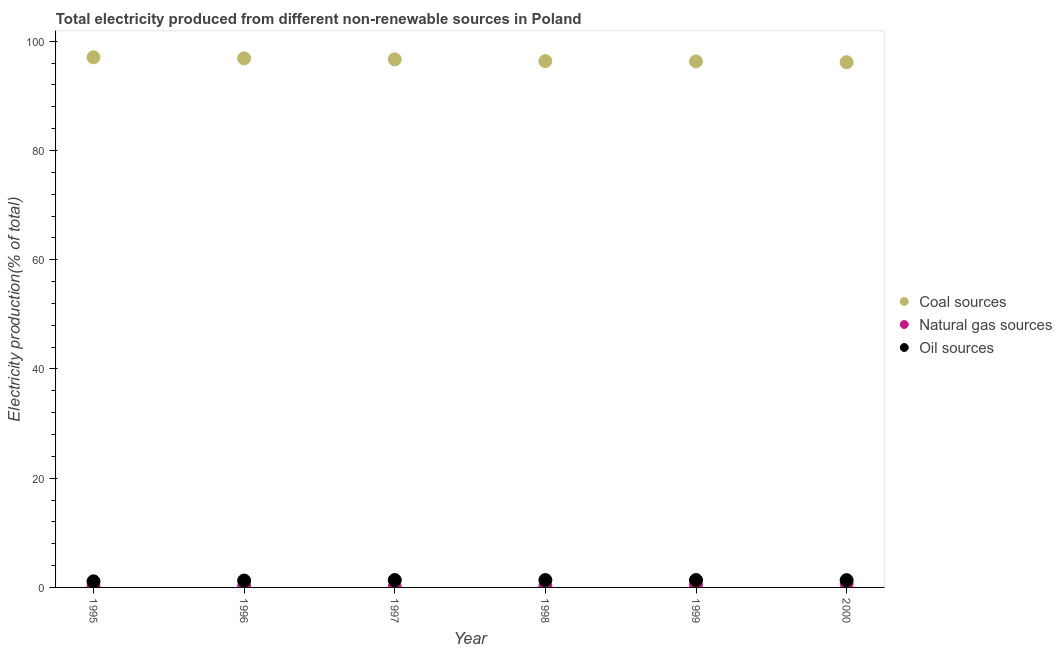How many different coloured dotlines are there?
Provide a succinct answer. 3. What is the percentage of electricity produced by natural gas in 1999?
Provide a short and direct response. 0.44. Across all years, what is the maximum percentage of electricity produced by oil sources?
Keep it short and to the point. 1.35. Across all years, what is the minimum percentage of electricity produced by natural gas?
Offer a terse response. 0.15. In which year was the percentage of electricity produced by oil sources maximum?
Your answer should be very brief. 1998. What is the total percentage of electricity produced by coal in the graph?
Offer a very short reply. 579.41. What is the difference between the percentage of electricity produced by oil sources in 1997 and that in 1998?
Your answer should be compact. -0. What is the difference between the percentage of electricity produced by oil sources in 1997 and the percentage of electricity produced by natural gas in 1998?
Provide a short and direct response. 1.13. What is the average percentage of electricity produced by natural gas per year?
Provide a succinct answer. 0.31. In the year 1999, what is the difference between the percentage of electricity produced by oil sources and percentage of electricity produced by natural gas?
Your answer should be very brief. 0.91. In how many years, is the percentage of electricity produced by natural gas greater than 80 %?
Offer a terse response. 0. What is the ratio of the percentage of electricity produced by oil sources in 1998 to that in 1999?
Keep it short and to the point. 1. Is the percentage of electricity produced by oil sources in 1998 less than that in 2000?
Offer a terse response. No. What is the difference between the highest and the second highest percentage of electricity produced by oil sources?
Offer a terse response. 0. What is the difference between the highest and the lowest percentage of electricity produced by coal?
Keep it short and to the point. 0.9. In how many years, is the percentage of electricity produced by natural gas greater than the average percentage of electricity produced by natural gas taken over all years?
Offer a very short reply. 2. Is the sum of the percentage of electricity produced by coal in 1995 and 1998 greater than the maximum percentage of electricity produced by natural gas across all years?
Make the answer very short. Yes. Does the percentage of electricity produced by natural gas monotonically increase over the years?
Your answer should be very brief. No. How many years are there in the graph?
Your answer should be compact. 6. What is the difference between two consecutive major ticks on the Y-axis?
Ensure brevity in your answer.  20. Are the values on the major ticks of Y-axis written in scientific E-notation?
Offer a terse response. No. Does the graph contain any zero values?
Your answer should be compact. No. Does the graph contain grids?
Your answer should be very brief. No. Where does the legend appear in the graph?
Keep it short and to the point. Center right. How many legend labels are there?
Provide a succinct answer. 3. What is the title of the graph?
Provide a short and direct response. Total electricity produced from different non-renewable sources in Poland. What is the Electricity production(% of total) in Coal sources in 1995?
Your answer should be very brief. 97.06. What is the Electricity production(% of total) in Natural gas sources in 1995?
Give a very brief answer. 0.19. What is the Electricity production(% of total) in Oil sources in 1995?
Your answer should be very brief. 1.11. What is the Electricity production(% of total) in Coal sources in 1996?
Your answer should be compact. 96.86. What is the Electricity production(% of total) of Natural gas sources in 1996?
Your answer should be compact. 0.23. What is the Electricity production(% of total) of Oil sources in 1996?
Your answer should be compact. 1.26. What is the Electricity production(% of total) in Coal sources in 1997?
Your answer should be very brief. 96.68. What is the Electricity production(% of total) in Natural gas sources in 1997?
Keep it short and to the point. 0.15. What is the Electricity production(% of total) in Oil sources in 1997?
Your answer should be compact. 1.35. What is the Electricity production(% of total) in Coal sources in 1998?
Provide a succinct answer. 96.36. What is the Electricity production(% of total) of Natural gas sources in 1998?
Provide a short and direct response. 0.22. What is the Electricity production(% of total) of Oil sources in 1998?
Give a very brief answer. 1.35. What is the Electricity production(% of total) in Coal sources in 1999?
Your response must be concise. 96.3. What is the Electricity production(% of total) in Natural gas sources in 1999?
Provide a short and direct response. 0.44. What is the Electricity production(% of total) in Oil sources in 1999?
Give a very brief answer. 1.35. What is the Electricity production(% of total) in Coal sources in 2000?
Offer a terse response. 96.15. What is the Electricity production(% of total) of Natural gas sources in 2000?
Give a very brief answer. 0.65. What is the Electricity production(% of total) of Oil sources in 2000?
Offer a terse response. 1.34. Across all years, what is the maximum Electricity production(% of total) of Coal sources?
Offer a very short reply. 97.06. Across all years, what is the maximum Electricity production(% of total) in Natural gas sources?
Provide a succinct answer. 0.65. Across all years, what is the maximum Electricity production(% of total) of Oil sources?
Ensure brevity in your answer.  1.35. Across all years, what is the minimum Electricity production(% of total) in Coal sources?
Make the answer very short. 96.15. Across all years, what is the minimum Electricity production(% of total) in Natural gas sources?
Give a very brief answer. 0.15. Across all years, what is the minimum Electricity production(% of total) in Oil sources?
Give a very brief answer. 1.11. What is the total Electricity production(% of total) in Coal sources in the graph?
Make the answer very short. 579.41. What is the total Electricity production(% of total) of Natural gas sources in the graph?
Your answer should be compact. 1.88. What is the total Electricity production(% of total) in Oil sources in the graph?
Your answer should be compact. 7.76. What is the difference between the Electricity production(% of total) of Coal sources in 1995 and that in 1996?
Keep it short and to the point. 0.19. What is the difference between the Electricity production(% of total) of Natural gas sources in 1995 and that in 1996?
Ensure brevity in your answer.  -0.04. What is the difference between the Electricity production(% of total) of Oil sources in 1995 and that in 1996?
Provide a succinct answer. -0.14. What is the difference between the Electricity production(% of total) in Coal sources in 1995 and that in 1997?
Offer a terse response. 0.38. What is the difference between the Electricity production(% of total) in Natural gas sources in 1995 and that in 1997?
Offer a very short reply. 0.04. What is the difference between the Electricity production(% of total) of Oil sources in 1995 and that in 1997?
Your answer should be compact. -0.24. What is the difference between the Electricity production(% of total) of Coal sources in 1995 and that in 1998?
Ensure brevity in your answer.  0.7. What is the difference between the Electricity production(% of total) in Natural gas sources in 1995 and that in 1998?
Make the answer very short. -0.03. What is the difference between the Electricity production(% of total) of Oil sources in 1995 and that in 1998?
Offer a terse response. -0.24. What is the difference between the Electricity production(% of total) in Coal sources in 1995 and that in 1999?
Give a very brief answer. 0.75. What is the difference between the Electricity production(% of total) of Natural gas sources in 1995 and that in 1999?
Offer a terse response. -0.25. What is the difference between the Electricity production(% of total) of Oil sources in 1995 and that in 1999?
Provide a succinct answer. -0.24. What is the difference between the Electricity production(% of total) in Coal sources in 1995 and that in 2000?
Offer a terse response. 0.9. What is the difference between the Electricity production(% of total) of Natural gas sources in 1995 and that in 2000?
Make the answer very short. -0.46. What is the difference between the Electricity production(% of total) in Oil sources in 1995 and that in 2000?
Offer a terse response. -0.23. What is the difference between the Electricity production(% of total) in Coal sources in 1996 and that in 1997?
Keep it short and to the point. 0.18. What is the difference between the Electricity production(% of total) of Natural gas sources in 1996 and that in 1997?
Your answer should be very brief. 0.08. What is the difference between the Electricity production(% of total) in Oil sources in 1996 and that in 1997?
Provide a short and direct response. -0.09. What is the difference between the Electricity production(% of total) of Coal sources in 1996 and that in 1998?
Your answer should be very brief. 0.5. What is the difference between the Electricity production(% of total) of Natural gas sources in 1996 and that in 1998?
Provide a short and direct response. 0.01. What is the difference between the Electricity production(% of total) of Oil sources in 1996 and that in 1998?
Offer a terse response. -0.1. What is the difference between the Electricity production(% of total) of Coal sources in 1996 and that in 1999?
Provide a succinct answer. 0.56. What is the difference between the Electricity production(% of total) of Natural gas sources in 1996 and that in 1999?
Ensure brevity in your answer.  -0.21. What is the difference between the Electricity production(% of total) of Oil sources in 1996 and that in 1999?
Make the answer very short. -0.1. What is the difference between the Electricity production(% of total) in Coal sources in 1996 and that in 2000?
Ensure brevity in your answer.  0.71. What is the difference between the Electricity production(% of total) in Natural gas sources in 1996 and that in 2000?
Make the answer very short. -0.42. What is the difference between the Electricity production(% of total) in Oil sources in 1996 and that in 2000?
Offer a terse response. -0.08. What is the difference between the Electricity production(% of total) of Coal sources in 1997 and that in 1998?
Offer a very short reply. 0.32. What is the difference between the Electricity production(% of total) of Natural gas sources in 1997 and that in 1998?
Your answer should be very brief. -0.07. What is the difference between the Electricity production(% of total) in Oil sources in 1997 and that in 1998?
Provide a short and direct response. -0. What is the difference between the Electricity production(% of total) in Coal sources in 1997 and that in 1999?
Make the answer very short. 0.38. What is the difference between the Electricity production(% of total) of Natural gas sources in 1997 and that in 1999?
Give a very brief answer. -0.29. What is the difference between the Electricity production(% of total) of Oil sources in 1997 and that in 1999?
Provide a succinct answer. -0. What is the difference between the Electricity production(% of total) in Coal sources in 1997 and that in 2000?
Ensure brevity in your answer.  0.52. What is the difference between the Electricity production(% of total) of Natural gas sources in 1997 and that in 2000?
Provide a succinct answer. -0.5. What is the difference between the Electricity production(% of total) in Oil sources in 1997 and that in 2000?
Offer a terse response. 0.01. What is the difference between the Electricity production(% of total) of Coal sources in 1998 and that in 1999?
Offer a terse response. 0.06. What is the difference between the Electricity production(% of total) of Natural gas sources in 1998 and that in 1999?
Offer a terse response. -0.22. What is the difference between the Electricity production(% of total) of Coal sources in 1998 and that in 2000?
Offer a terse response. 0.21. What is the difference between the Electricity production(% of total) in Natural gas sources in 1998 and that in 2000?
Your answer should be very brief. -0.43. What is the difference between the Electricity production(% of total) of Oil sources in 1998 and that in 2000?
Your answer should be very brief. 0.01. What is the difference between the Electricity production(% of total) in Coal sources in 1999 and that in 2000?
Offer a terse response. 0.15. What is the difference between the Electricity production(% of total) in Natural gas sources in 1999 and that in 2000?
Your response must be concise. -0.21. What is the difference between the Electricity production(% of total) of Oil sources in 1999 and that in 2000?
Make the answer very short. 0.01. What is the difference between the Electricity production(% of total) in Coal sources in 1995 and the Electricity production(% of total) in Natural gas sources in 1996?
Ensure brevity in your answer.  96.83. What is the difference between the Electricity production(% of total) in Coal sources in 1995 and the Electricity production(% of total) in Oil sources in 1996?
Provide a succinct answer. 95.8. What is the difference between the Electricity production(% of total) of Natural gas sources in 1995 and the Electricity production(% of total) of Oil sources in 1996?
Keep it short and to the point. -1.07. What is the difference between the Electricity production(% of total) in Coal sources in 1995 and the Electricity production(% of total) in Natural gas sources in 1997?
Provide a short and direct response. 96.9. What is the difference between the Electricity production(% of total) of Coal sources in 1995 and the Electricity production(% of total) of Oil sources in 1997?
Ensure brevity in your answer.  95.71. What is the difference between the Electricity production(% of total) of Natural gas sources in 1995 and the Electricity production(% of total) of Oil sources in 1997?
Your answer should be very brief. -1.16. What is the difference between the Electricity production(% of total) of Coal sources in 1995 and the Electricity production(% of total) of Natural gas sources in 1998?
Keep it short and to the point. 96.83. What is the difference between the Electricity production(% of total) in Coal sources in 1995 and the Electricity production(% of total) in Oil sources in 1998?
Provide a succinct answer. 95.71. What is the difference between the Electricity production(% of total) in Natural gas sources in 1995 and the Electricity production(% of total) in Oil sources in 1998?
Give a very brief answer. -1.16. What is the difference between the Electricity production(% of total) in Coal sources in 1995 and the Electricity production(% of total) in Natural gas sources in 1999?
Make the answer very short. 96.61. What is the difference between the Electricity production(% of total) of Coal sources in 1995 and the Electricity production(% of total) of Oil sources in 1999?
Offer a very short reply. 95.71. What is the difference between the Electricity production(% of total) of Natural gas sources in 1995 and the Electricity production(% of total) of Oil sources in 1999?
Provide a short and direct response. -1.16. What is the difference between the Electricity production(% of total) of Coal sources in 1995 and the Electricity production(% of total) of Natural gas sources in 2000?
Your answer should be very brief. 96.41. What is the difference between the Electricity production(% of total) of Coal sources in 1995 and the Electricity production(% of total) of Oil sources in 2000?
Your response must be concise. 95.72. What is the difference between the Electricity production(% of total) of Natural gas sources in 1995 and the Electricity production(% of total) of Oil sources in 2000?
Your answer should be compact. -1.15. What is the difference between the Electricity production(% of total) of Coal sources in 1996 and the Electricity production(% of total) of Natural gas sources in 1997?
Provide a succinct answer. 96.71. What is the difference between the Electricity production(% of total) in Coal sources in 1996 and the Electricity production(% of total) in Oil sources in 1997?
Keep it short and to the point. 95.51. What is the difference between the Electricity production(% of total) of Natural gas sources in 1996 and the Electricity production(% of total) of Oil sources in 1997?
Your response must be concise. -1.12. What is the difference between the Electricity production(% of total) in Coal sources in 1996 and the Electricity production(% of total) in Natural gas sources in 1998?
Your answer should be very brief. 96.64. What is the difference between the Electricity production(% of total) of Coal sources in 1996 and the Electricity production(% of total) of Oil sources in 1998?
Your answer should be compact. 95.51. What is the difference between the Electricity production(% of total) in Natural gas sources in 1996 and the Electricity production(% of total) in Oil sources in 1998?
Give a very brief answer. -1.12. What is the difference between the Electricity production(% of total) in Coal sources in 1996 and the Electricity production(% of total) in Natural gas sources in 1999?
Give a very brief answer. 96.42. What is the difference between the Electricity production(% of total) of Coal sources in 1996 and the Electricity production(% of total) of Oil sources in 1999?
Make the answer very short. 95.51. What is the difference between the Electricity production(% of total) of Natural gas sources in 1996 and the Electricity production(% of total) of Oil sources in 1999?
Your answer should be compact. -1.12. What is the difference between the Electricity production(% of total) of Coal sources in 1996 and the Electricity production(% of total) of Natural gas sources in 2000?
Provide a short and direct response. 96.21. What is the difference between the Electricity production(% of total) of Coal sources in 1996 and the Electricity production(% of total) of Oil sources in 2000?
Offer a very short reply. 95.52. What is the difference between the Electricity production(% of total) in Natural gas sources in 1996 and the Electricity production(% of total) in Oil sources in 2000?
Provide a succinct answer. -1.11. What is the difference between the Electricity production(% of total) in Coal sources in 1997 and the Electricity production(% of total) in Natural gas sources in 1998?
Ensure brevity in your answer.  96.46. What is the difference between the Electricity production(% of total) of Coal sources in 1997 and the Electricity production(% of total) of Oil sources in 1998?
Your answer should be very brief. 95.33. What is the difference between the Electricity production(% of total) of Natural gas sources in 1997 and the Electricity production(% of total) of Oil sources in 1998?
Your answer should be compact. -1.2. What is the difference between the Electricity production(% of total) of Coal sources in 1997 and the Electricity production(% of total) of Natural gas sources in 1999?
Ensure brevity in your answer.  96.23. What is the difference between the Electricity production(% of total) of Coal sources in 1997 and the Electricity production(% of total) of Oil sources in 1999?
Ensure brevity in your answer.  95.33. What is the difference between the Electricity production(% of total) of Natural gas sources in 1997 and the Electricity production(% of total) of Oil sources in 1999?
Ensure brevity in your answer.  -1.2. What is the difference between the Electricity production(% of total) of Coal sources in 1997 and the Electricity production(% of total) of Natural gas sources in 2000?
Your answer should be very brief. 96.03. What is the difference between the Electricity production(% of total) of Coal sources in 1997 and the Electricity production(% of total) of Oil sources in 2000?
Your answer should be very brief. 95.34. What is the difference between the Electricity production(% of total) of Natural gas sources in 1997 and the Electricity production(% of total) of Oil sources in 2000?
Provide a short and direct response. -1.19. What is the difference between the Electricity production(% of total) in Coal sources in 1998 and the Electricity production(% of total) in Natural gas sources in 1999?
Offer a terse response. 95.92. What is the difference between the Electricity production(% of total) of Coal sources in 1998 and the Electricity production(% of total) of Oil sources in 1999?
Ensure brevity in your answer.  95.01. What is the difference between the Electricity production(% of total) of Natural gas sources in 1998 and the Electricity production(% of total) of Oil sources in 1999?
Offer a very short reply. -1.13. What is the difference between the Electricity production(% of total) in Coal sources in 1998 and the Electricity production(% of total) in Natural gas sources in 2000?
Offer a terse response. 95.71. What is the difference between the Electricity production(% of total) in Coal sources in 1998 and the Electricity production(% of total) in Oil sources in 2000?
Provide a succinct answer. 95.02. What is the difference between the Electricity production(% of total) in Natural gas sources in 1998 and the Electricity production(% of total) in Oil sources in 2000?
Your response must be concise. -1.12. What is the difference between the Electricity production(% of total) in Coal sources in 1999 and the Electricity production(% of total) in Natural gas sources in 2000?
Ensure brevity in your answer.  95.65. What is the difference between the Electricity production(% of total) of Coal sources in 1999 and the Electricity production(% of total) of Oil sources in 2000?
Make the answer very short. 94.96. What is the difference between the Electricity production(% of total) of Natural gas sources in 1999 and the Electricity production(% of total) of Oil sources in 2000?
Offer a very short reply. -0.9. What is the average Electricity production(% of total) in Coal sources per year?
Give a very brief answer. 96.57. What is the average Electricity production(% of total) in Natural gas sources per year?
Provide a succinct answer. 0.31. What is the average Electricity production(% of total) of Oil sources per year?
Provide a succinct answer. 1.29. In the year 1995, what is the difference between the Electricity production(% of total) of Coal sources and Electricity production(% of total) of Natural gas sources?
Give a very brief answer. 96.87. In the year 1995, what is the difference between the Electricity production(% of total) in Coal sources and Electricity production(% of total) in Oil sources?
Your answer should be compact. 95.95. In the year 1995, what is the difference between the Electricity production(% of total) in Natural gas sources and Electricity production(% of total) in Oil sources?
Make the answer very short. -0.92. In the year 1996, what is the difference between the Electricity production(% of total) in Coal sources and Electricity production(% of total) in Natural gas sources?
Ensure brevity in your answer.  96.63. In the year 1996, what is the difference between the Electricity production(% of total) of Coal sources and Electricity production(% of total) of Oil sources?
Offer a terse response. 95.61. In the year 1996, what is the difference between the Electricity production(% of total) in Natural gas sources and Electricity production(% of total) in Oil sources?
Give a very brief answer. -1.03. In the year 1997, what is the difference between the Electricity production(% of total) of Coal sources and Electricity production(% of total) of Natural gas sources?
Make the answer very short. 96.53. In the year 1997, what is the difference between the Electricity production(% of total) of Coal sources and Electricity production(% of total) of Oil sources?
Your answer should be very brief. 95.33. In the year 1997, what is the difference between the Electricity production(% of total) in Natural gas sources and Electricity production(% of total) in Oil sources?
Keep it short and to the point. -1.2. In the year 1998, what is the difference between the Electricity production(% of total) in Coal sources and Electricity production(% of total) in Natural gas sources?
Keep it short and to the point. 96.14. In the year 1998, what is the difference between the Electricity production(% of total) in Coal sources and Electricity production(% of total) in Oil sources?
Make the answer very short. 95.01. In the year 1998, what is the difference between the Electricity production(% of total) of Natural gas sources and Electricity production(% of total) of Oil sources?
Keep it short and to the point. -1.13. In the year 1999, what is the difference between the Electricity production(% of total) in Coal sources and Electricity production(% of total) in Natural gas sources?
Keep it short and to the point. 95.86. In the year 1999, what is the difference between the Electricity production(% of total) of Coal sources and Electricity production(% of total) of Oil sources?
Ensure brevity in your answer.  94.95. In the year 1999, what is the difference between the Electricity production(% of total) of Natural gas sources and Electricity production(% of total) of Oil sources?
Give a very brief answer. -0.91. In the year 2000, what is the difference between the Electricity production(% of total) of Coal sources and Electricity production(% of total) of Natural gas sources?
Give a very brief answer. 95.51. In the year 2000, what is the difference between the Electricity production(% of total) in Coal sources and Electricity production(% of total) in Oil sources?
Your answer should be compact. 94.82. In the year 2000, what is the difference between the Electricity production(% of total) of Natural gas sources and Electricity production(% of total) of Oil sources?
Your answer should be compact. -0.69. What is the ratio of the Electricity production(% of total) in Natural gas sources in 1995 to that in 1996?
Your answer should be compact. 0.82. What is the ratio of the Electricity production(% of total) in Oil sources in 1995 to that in 1996?
Provide a short and direct response. 0.89. What is the ratio of the Electricity production(% of total) of Coal sources in 1995 to that in 1997?
Offer a terse response. 1. What is the ratio of the Electricity production(% of total) of Natural gas sources in 1995 to that in 1997?
Your response must be concise. 1.23. What is the ratio of the Electricity production(% of total) of Oil sources in 1995 to that in 1997?
Offer a very short reply. 0.82. What is the ratio of the Electricity production(% of total) of Natural gas sources in 1995 to that in 1998?
Offer a terse response. 0.85. What is the ratio of the Electricity production(% of total) in Oil sources in 1995 to that in 1998?
Your answer should be compact. 0.82. What is the ratio of the Electricity production(% of total) in Coal sources in 1995 to that in 1999?
Your answer should be very brief. 1.01. What is the ratio of the Electricity production(% of total) in Natural gas sources in 1995 to that in 1999?
Provide a succinct answer. 0.43. What is the ratio of the Electricity production(% of total) in Oil sources in 1995 to that in 1999?
Offer a very short reply. 0.82. What is the ratio of the Electricity production(% of total) in Coal sources in 1995 to that in 2000?
Offer a terse response. 1.01. What is the ratio of the Electricity production(% of total) in Natural gas sources in 1995 to that in 2000?
Your answer should be very brief. 0.29. What is the ratio of the Electricity production(% of total) in Oil sources in 1995 to that in 2000?
Provide a short and direct response. 0.83. What is the ratio of the Electricity production(% of total) in Natural gas sources in 1996 to that in 1997?
Your answer should be very brief. 1.5. What is the ratio of the Electricity production(% of total) in Oil sources in 1996 to that in 1997?
Your response must be concise. 0.93. What is the ratio of the Electricity production(% of total) in Natural gas sources in 1996 to that in 1998?
Provide a succinct answer. 1.03. What is the ratio of the Electricity production(% of total) in Oil sources in 1996 to that in 1998?
Ensure brevity in your answer.  0.93. What is the ratio of the Electricity production(% of total) in Coal sources in 1996 to that in 1999?
Provide a succinct answer. 1.01. What is the ratio of the Electricity production(% of total) in Natural gas sources in 1996 to that in 1999?
Your answer should be compact. 0.52. What is the ratio of the Electricity production(% of total) of Oil sources in 1996 to that in 1999?
Keep it short and to the point. 0.93. What is the ratio of the Electricity production(% of total) of Coal sources in 1996 to that in 2000?
Ensure brevity in your answer.  1.01. What is the ratio of the Electricity production(% of total) of Natural gas sources in 1996 to that in 2000?
Offer a terse response. 0.35. What is the ratio of the Electricity production(% of total) in Oil sources in 1996 to that in 2000?
Offer a very short reply. 0.94. What is the ratio of the Electricity production(% of total) in Coal sources in 1997 to that in 1998?
Give a very brief answer. 1. What is the ratio of the Electricity production(% of total) in Natural gas sources in 1997 to that in 1998?
Your response must be concise. 0.69. What is the ratio of the Electricity production(% of total) of Oil sources in 1997 to that in 1998?
Make the answer very short. 1. What is the ratio of the Electricity production(% of total) of Coal sources in 1997 to that in 1999?
Your answer should be very brief. 1. What is the ratio of the Electricity production(% of total) of Natural gas sources in 1997 to that in 1999?
Ensure brevity in your answer.  0.34. What is the ratio of the Electricity production(% of total) in Oil sources in 1997 to that in 1999?
Provide a succinct answer. 1. What is the ratio of the Electricity production(% of total) of Natural gas sources in 1997 to that in 2000?
Give a very brief answer. 0.24. What is the ratio of the Electricity production(% of total) in Oil sources in 1997 to that in 2000?
Offer a very short reply. 1.01. What is the ratio of the Electricity production(% of total) of Coal sources in 1998 to that in 1999?
Provide a succinct answer. 1. What is the ratio of the Electricity production(% of total) in Natural gas sources in 1998 to that in 1999?
Make the answer very short. 0.5. What is the ratio of the Electricity production(% of total) in Coal sources in 1998 to that in 2000?
Provide a short and direct response. 1. What is the ratio of the Electricity production(% of total) in Natural gas sources in 1998 to that in 2000?
Keep it short and to the point. 0.34. What is the ratio of the Electricity production(% of total) in Oil sources in 1998 to that in 2000?
Give a very brief answer. 1.01. What is the ratio of the Electricity production(% of total) in Coal sources in 1999 to that in 2000?
Give a very brief answer. 1. What is the ratio of the Electricity production(% of total) of Natural gas sources in 1999 to that in 2000?
Provide a short and direct response. 0.68. What is the ratio of the Electricity production(% of total) in Oil sources in 1999 to that in 2000?
Provide a succinct answer. 1.01. What is the difference between the highest and the second highest Electricity production(% of total) of Coal sources?
Your answer should be compact. 0.19. What is the difference between the highest and the second highest Electricity production(% of total) of Natural gas sources?
Provide a succinct answer. 0.21. What is the difference between the highest and the second highest Electricity production(% of total) in Oil sources?
Your answer should be very brief. 0. What is the difference between the highest and the lowest Electricity production(% of total) in Coal sources?
Provide a short and direct response. 0.9. What is the difference between the highest and the lowest Electricity production(% of total) in Natural gas sources?
Provide a short and direct response. 0.5. What is the difference between the highest and the lowest Electricity production(% of total) of Oil sources?
Make the answer very short. 0.24. 